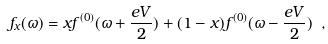<formula> <loc_0><loc_0><loc_500><loc_500>f _ { x } ( \omega ) = x f ^ { ( 0 ) } ( \omega + \frac { e V } { 2 } ) + ( 1 - x ) f ^ { ( 0 ) } ( \omega - \frac { e V } { 2 } ) \ ,</formula> 